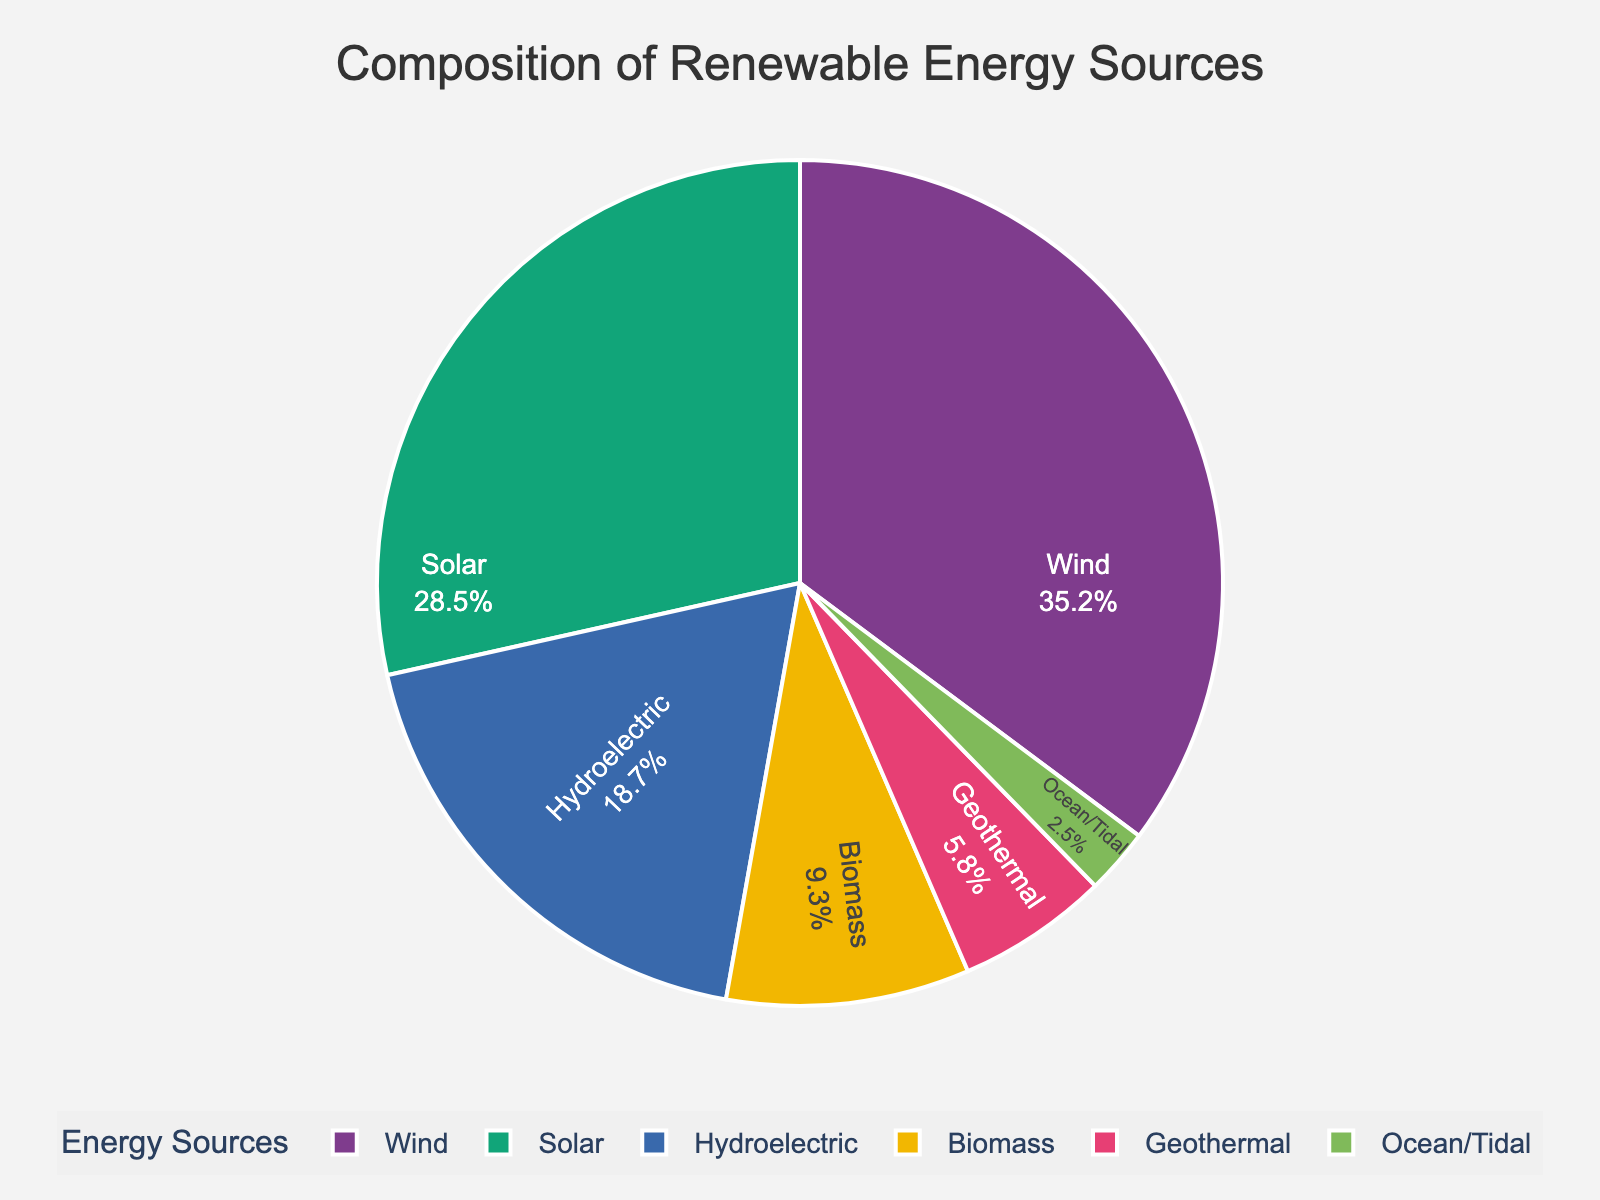How many more percentage points of energy does Wind contribute compared to Solar? To answer this, subtract the percentage of Solar from the percentage of Wind: 35.2% (Wind) - 28.5% (Solar) = 6.7 percentage points.
Answer: 6.7 percentage points What is the total percentage of energy accounted for by Biomass and Geothermal combined? Add the percentage of Biomass to the percentage of Geothermal: 9.3% (Biomass) + 5.8% (Geothermal) = 15.1%.
Answer: 15.1% Which renewable energy source contributes the least to the state's power grid? Identify the source with the smallest percentage: Ocean/Tidal at 2.5%.
Answer: Ocean/Tidal Is the percentage of energy from Hydroelectric greater than the percentage from Biomass and Ocean/Tidal combined? First, add the percentages of Biomass and Ocean/Tidal: 9.3% + 2.5% = 11.8%. Then compare Hydroelectric (18.7%) to 11.8%. Since 18.7% > 11.8%, Hydroelectric is greater.
Answer: Yes What is the percentage difference between the largest and smallest energy sources? Identify the largest (Wind at 35.2%) and smallest (Ocean/Tidal at 2.5%). Subtract the smallest from the largest: 35.2% - 2.5% = 32.7%.
Answer: 32.7% Rank the renewable energy sources from highest to lowest percentage contribution. List each source and its percentage, then order them from highest to lowest:
1. Wind (35.2%)
2. Solar (28.5%)
3. Hydroelectric (18.7%)
4. Biomass (9.3%)
5. Geothermal (5.8%)
6. Ocean/Tidal (2.5%)
Answer: Wind, Solar, Hydroelectric, Biomass, Geothermal, Ocean/Tidal What is the average percentage contribution of Solar, Biomass, and Ocean/Tidal combined? First, add the percentages together: 28.5% (Solar) + 9.3% (Biomass) + 2.5% (Ocean/Tidal) = 40.3%. Then divide by the number of sources: 40.3% / 3 = approximately 13.4%.
Answer: 13.4% Is the sum of the percentage contributions from Solar and Wind greater than 50%? Add the percentages of Solar and Wind: 28.5% + 35.2% = 63.7%. Since 63.7% > 50%, it is greater.
Answer: Yes 